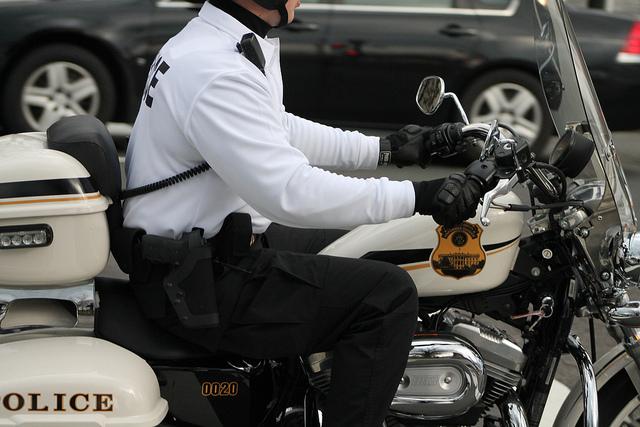What is this person sitting on?
Write a very short answer. Motorcycle. Which branch of public service does the man belong?
Concise answer only. Police. What color are his gloves?
Give a very brief answer. Black. 